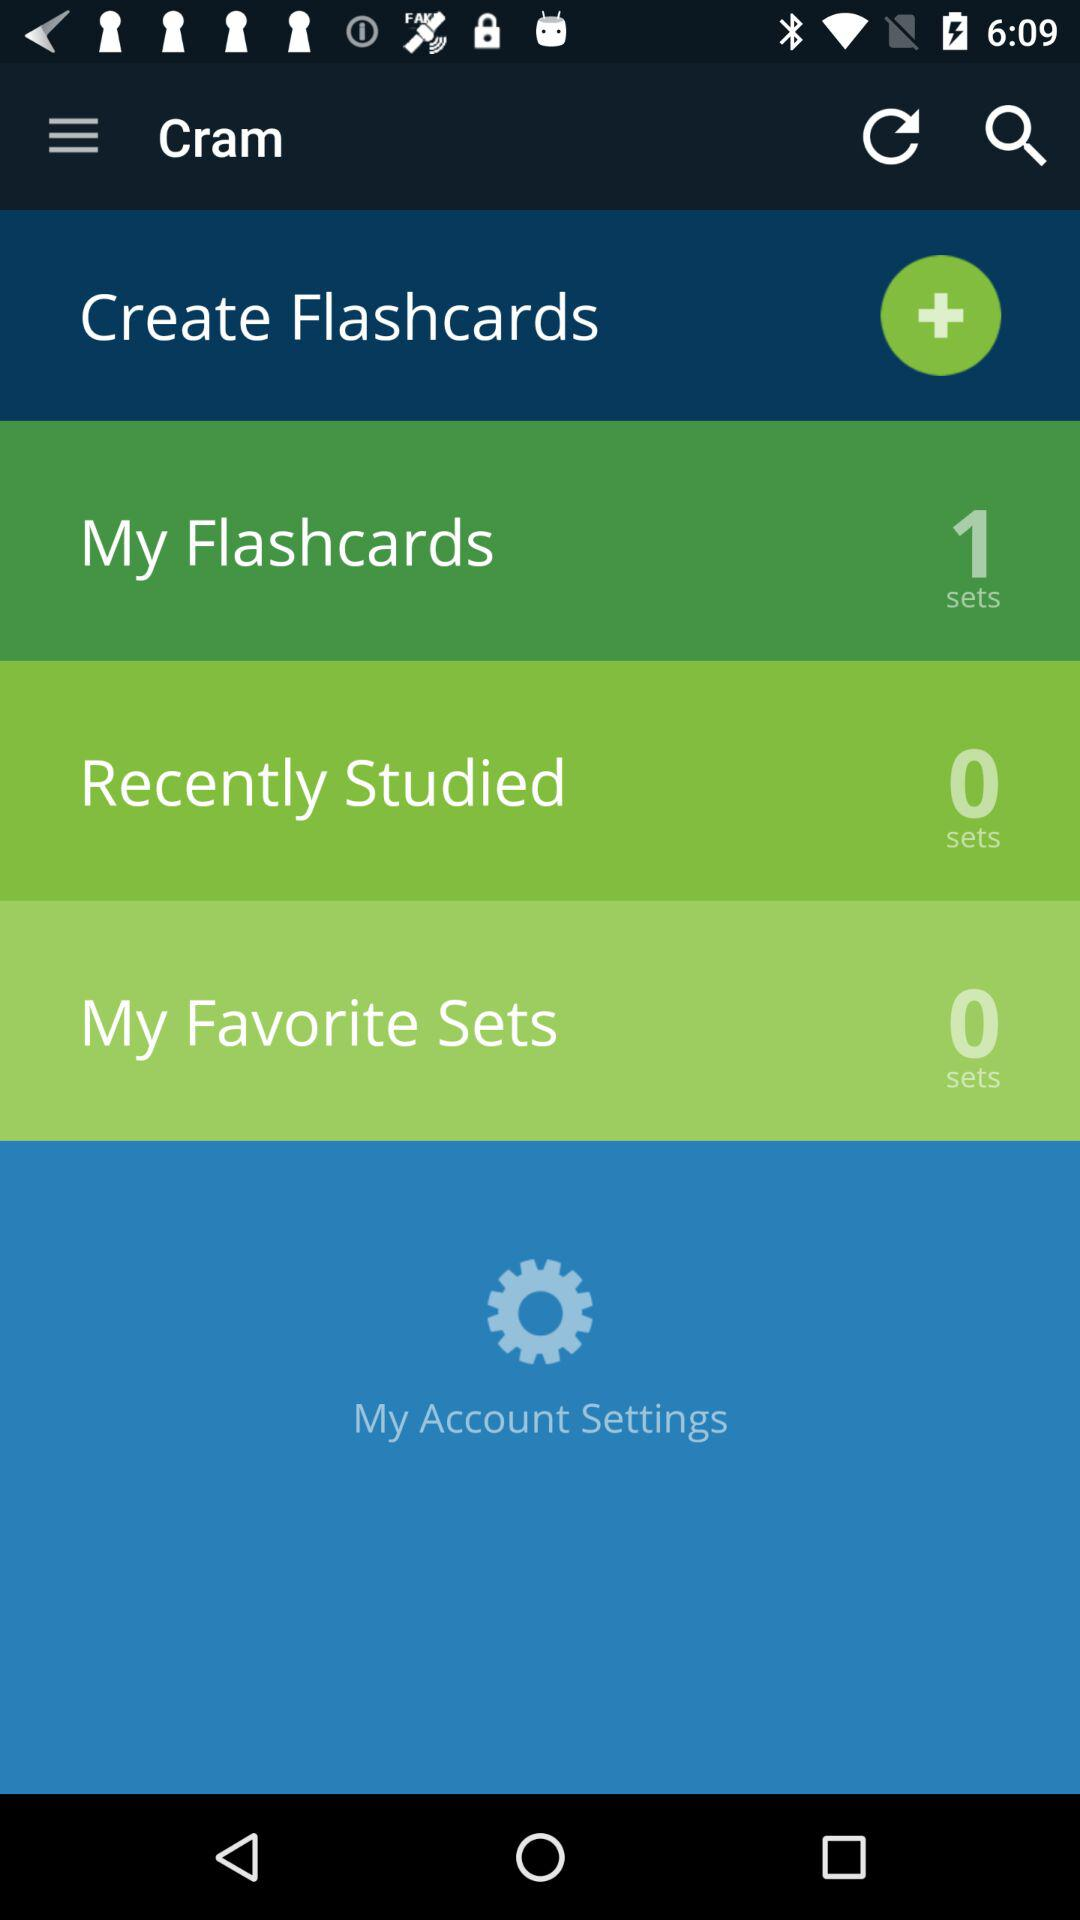How many sets of "My Flashcards" are created? The number of sets of "My Flashcards" created is 1. 